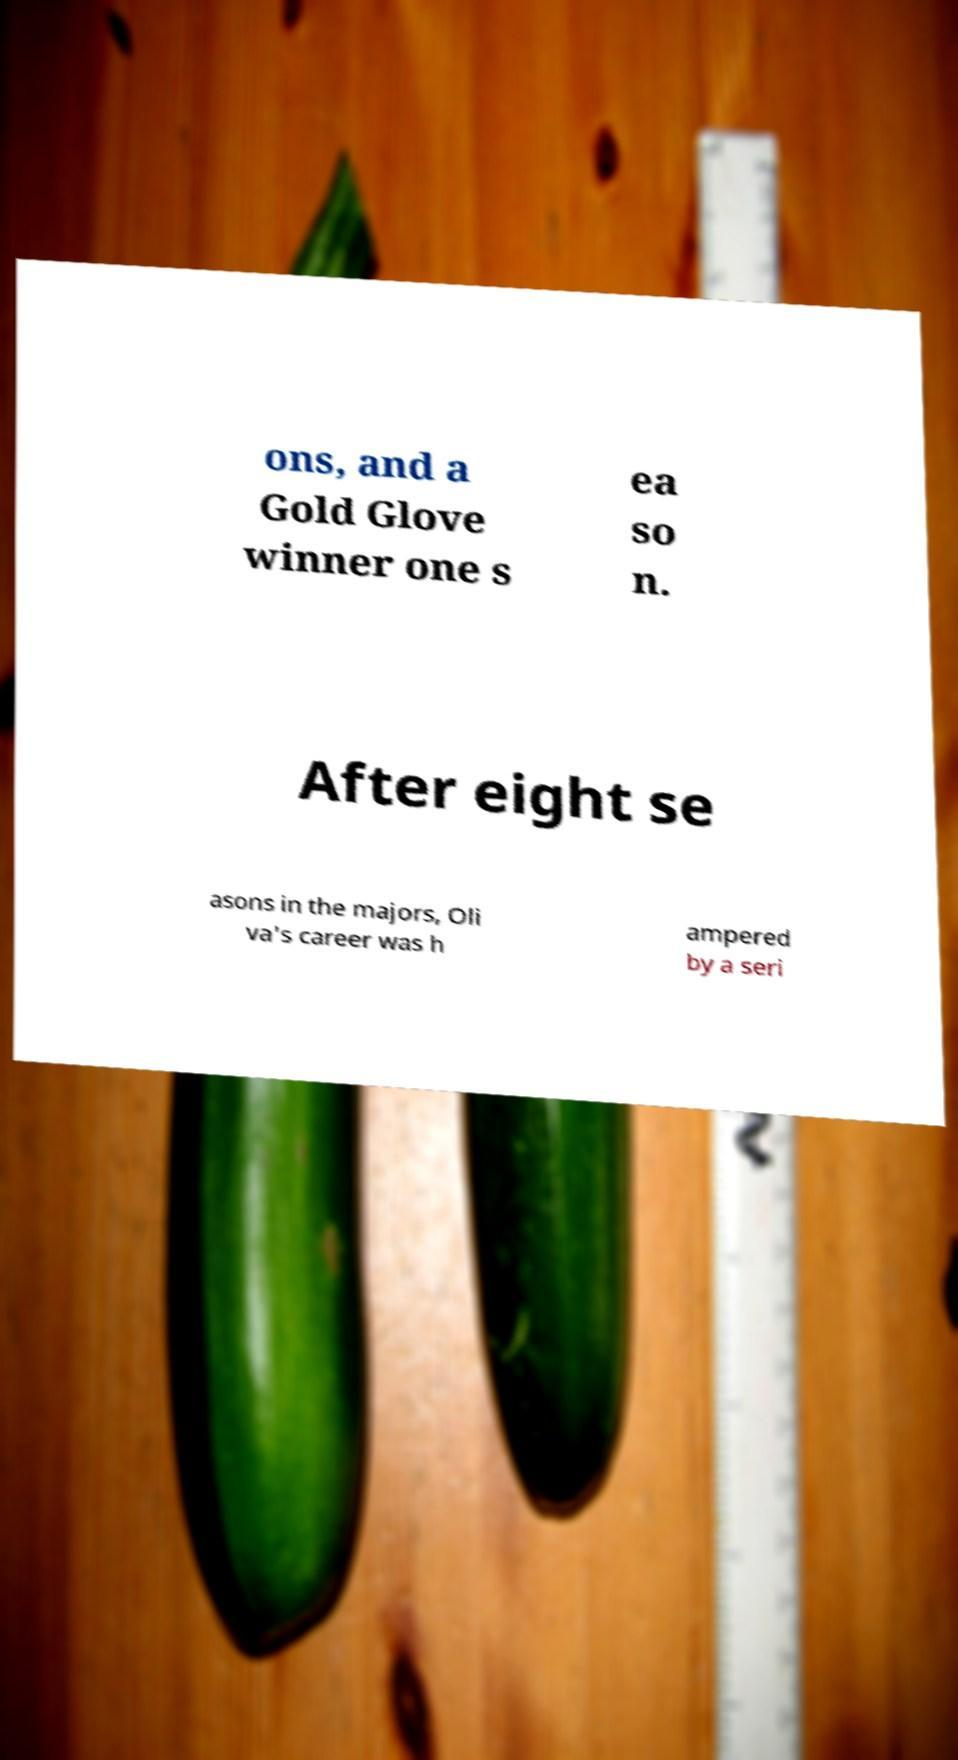There's text embedded in this image that I need extracted. Can you transcribe it verbatim? ons, and a Gold Glove winner one s ea so n. After eight se asons in the majors, Oli va's career was h ampered by a seri 